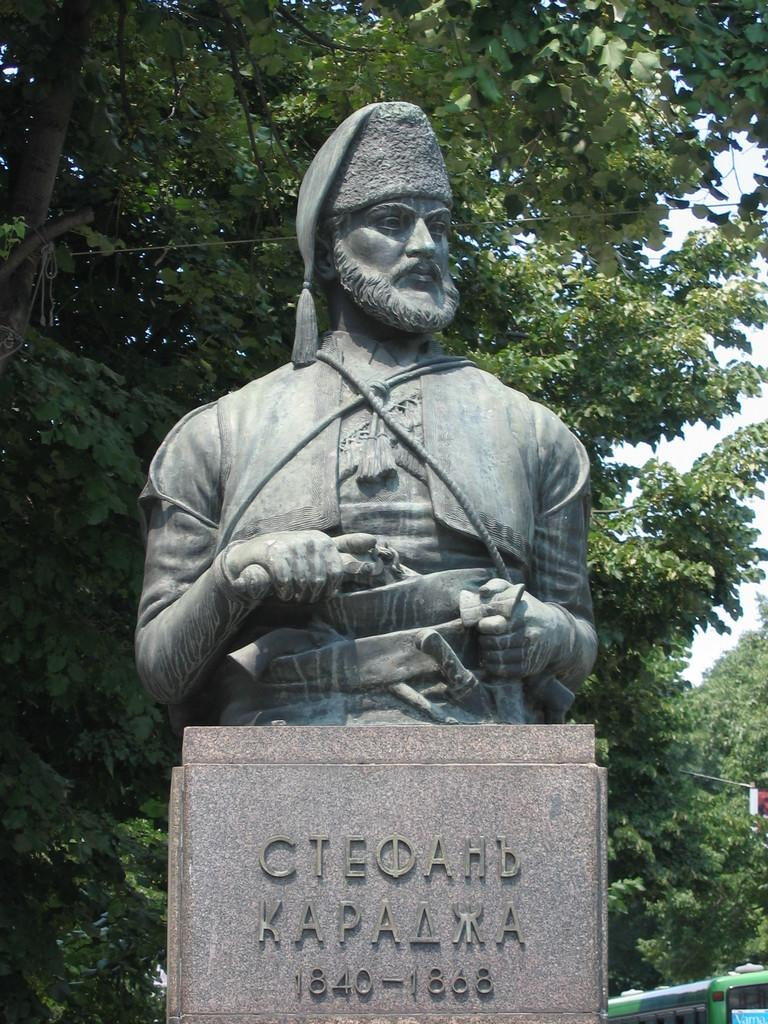What is the main subject in the center of the image? There is a statue in the center of the image. What can be seen in the background of the image? There are trees and the sky visible in the background of the image. How many straws are attached to the statue in the image? There are no straws present in the image; the statue is the main subject. 